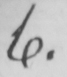Can you read and transcribe this handwriting? 4 . 